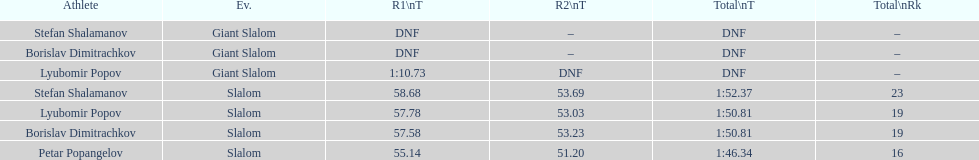Who was last in the slalom overall? Stefan Shalamanov. 